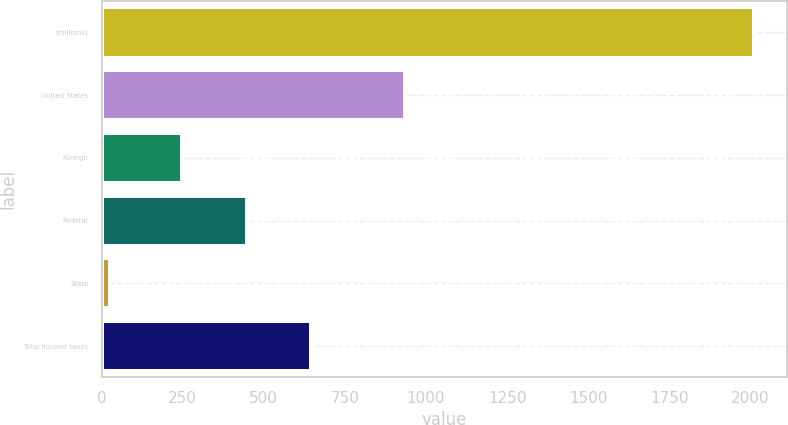<chart> <loc_0><loc_0><loc_500><loc_500><bar_chart><fcel>(millions)<fcel>United States<fcel>Foreign<fcel>Federal<fcel>State<fcel>Total income taxes<nl><fcel>2011<fcel>935<fcel>249<fcel>447.5<fcel>26<fcel>646<nl></chart> 